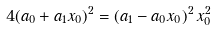<formula> <loc_0><loc_0><loc_500><loc_500>4 ( a _ { 0 } + a _ { 1 } x _ { 0 } ) ^ { 2 } = ( a _ { 1 } - a _ { 0 } x _ { 0 } ) ^ { 2 } \, x _ { 0 } ^ { 2 }</formula> 